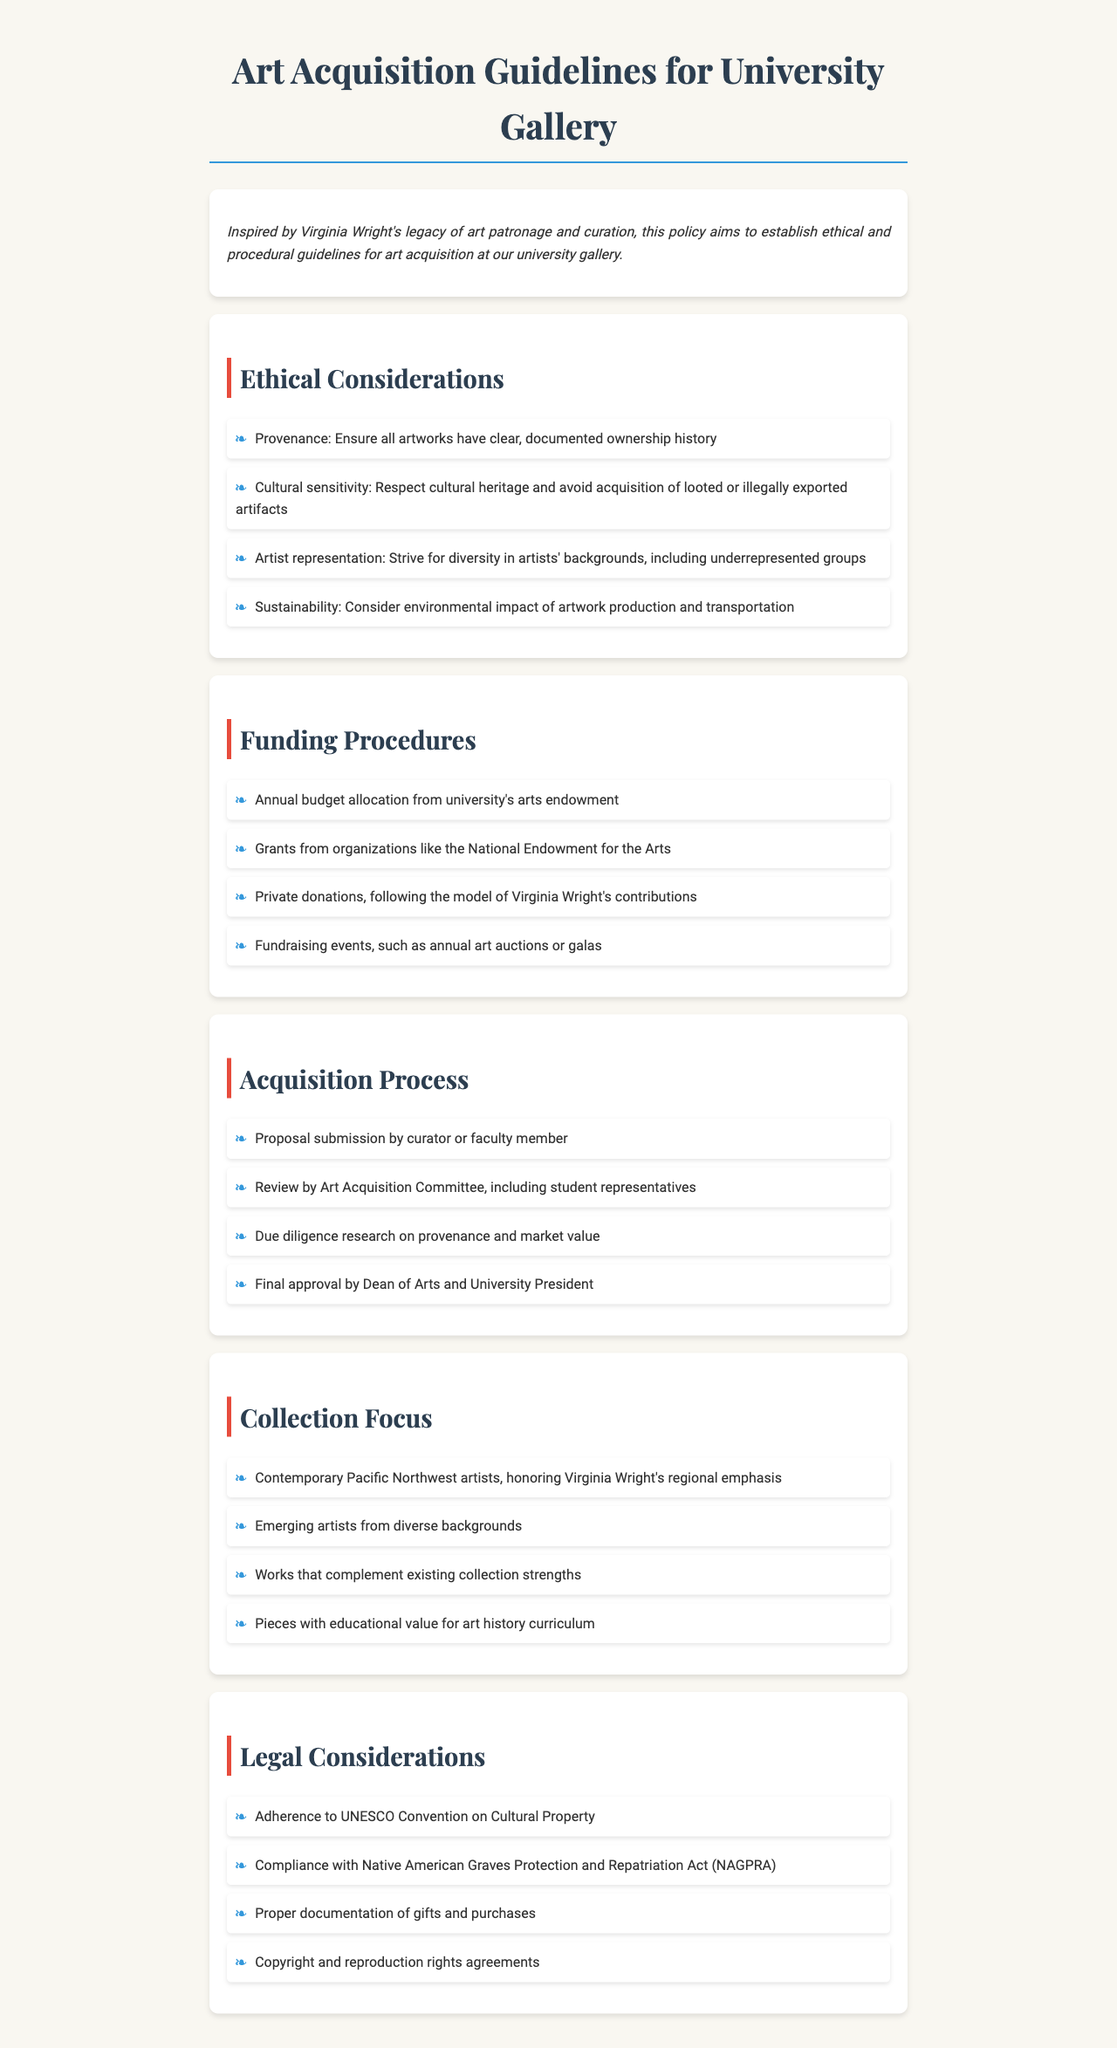what is the main inspiration for these guidelines? The introduction specifies that the guidelines are inspired by Virginia Wright's legacy of art patronage and curation.
Answer: Virginia Wright's legacy what is one ethical consideration mentioned in the document? The ethical considerations section lists several factors, one of which is "provenance."
Answer: Provenance who is responsible for final approval of acquisitions? The acquisition process specifies that the Dean of Arts and University President are responsible for final approval.
Answer: Dean of Arts and University President how can the gallery receive private funding? The funding procedures mention private donations modeled after Virginia Wright's contributions as a source of funding.
Answer: Private donations what is the focus of the collection? The collection focus section highlights contemporary Pacific Northwest artists as an emphasis in the acquisition strategy.
Answer: Contemporary Pacific Northwest artists what legal compliance guideline is mentioned in the document? The legal considerations section specifies adherence to the "UNESCO Convention on Cultural Property" as a legal compliance guideline.
Answer: UNESCO Convention on Cultural Property how is the Art Acquisition Committee composed? The acquisition process states that the committee includes student representatives, suggesting that it incorporates a diverse group.
Answer: Student representatives what type of events does the gallery hold for fundraising? The funding procedures outline that the gallery holds "annual art auctions or galas" for fundraising.
Answer: Annual art auctions or galas 